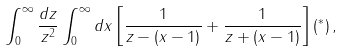Convert formula to latex. <formula><loc_0><loc_0><loc_500><loc_500>\int _ { 0 } ^ { \infty } { \frac { d z } { z ^ { 2 } } } \int _ { 0 } ^ { \infty } d x \left [ { \frac { 1 } { z - ( x - 1 ) } } + { \frac { 1 } { z + ( x - 1 ) } } \right ] ( ^ { * } ) \, ,</formula> 